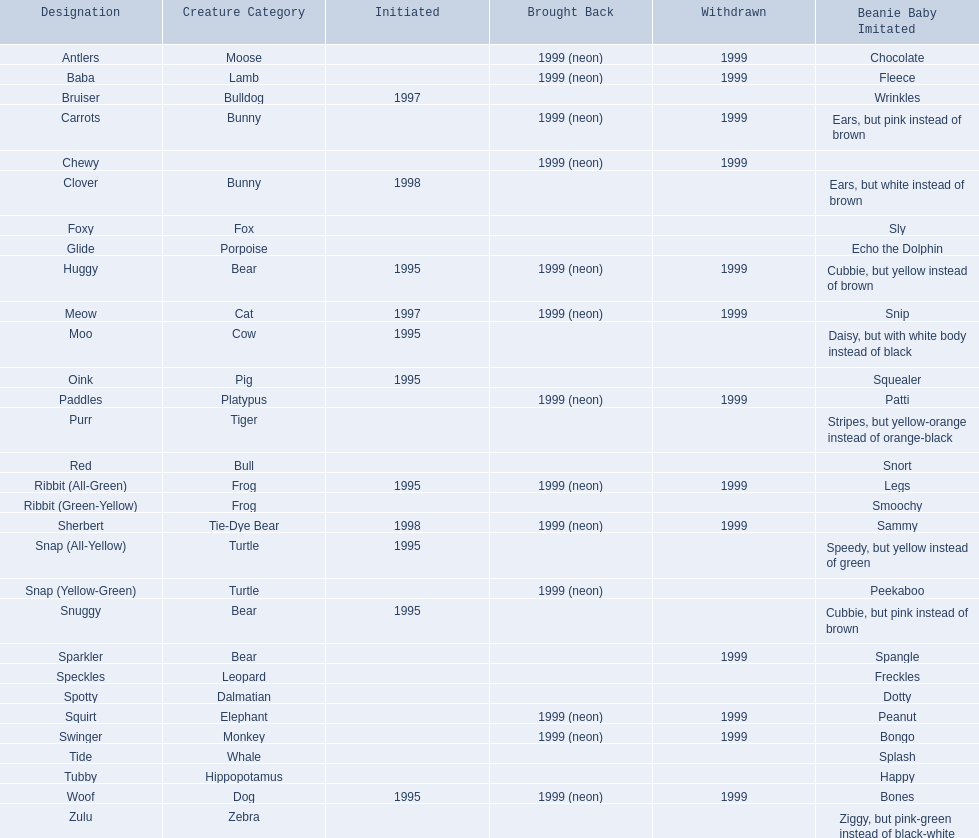Which of the listed pillow pals lack information in at least 3 categories? Chewy, Foxy, Glide, Purr, Red, Ribbit (Green-Yellow), Speckles, Spotty, Tide, Tubby, Zulu. Of those, which one lacks information in the animal type category? Chewy. 